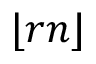<formula> <loc_0><loc_0><loc_500><loc_500>\lfloor r n \rfloor</formula> 